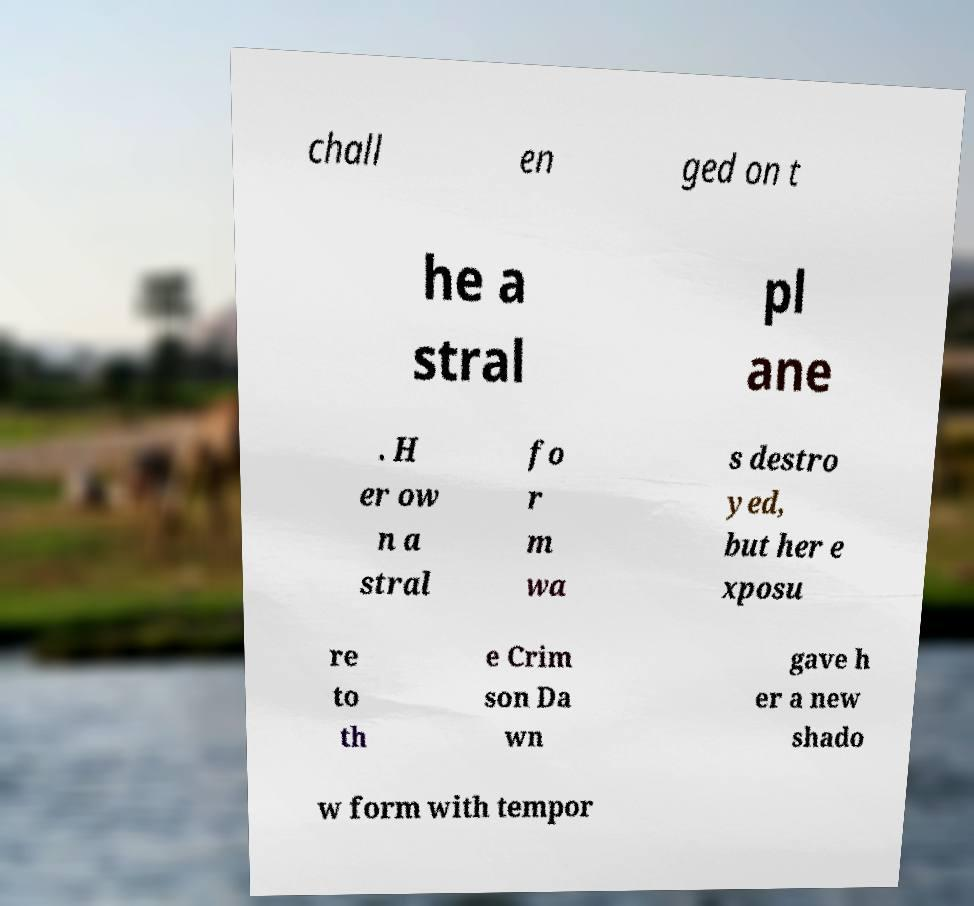Please read and relay the text visible in this image. What does it say? chall en ged on t he a stral pl ane . H er ow n a stral fo r m wa s destro yed, but her e xposu re to th e Crim son Da wn gave h er a new shado w form with tempor 